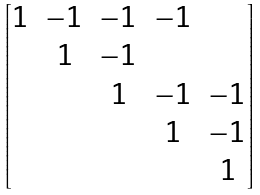<formula> <loc_0><loc_0><loc_500><loc_500>\begin{bmatrix} 1 & - 1 & - 1 & - 1 & \\ & 1 & - 1 & & \\ & & 1 & - 1 & - 1 \\ & & & 1 & - 1 \\ & & & & 1 \end{bmatrix}</formula> 